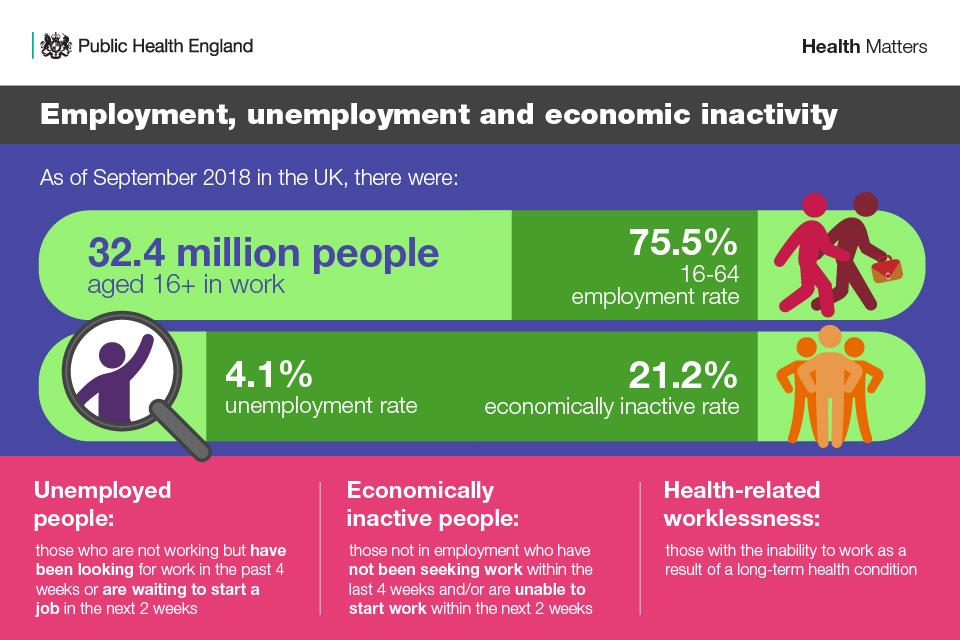Give some essential details in this illustration. The unemployment rate in the UK as of September 2018 was 4.1%. As of September 2018, the employment rate of individuals aged 16-64 years in the UK was 75.5%. 